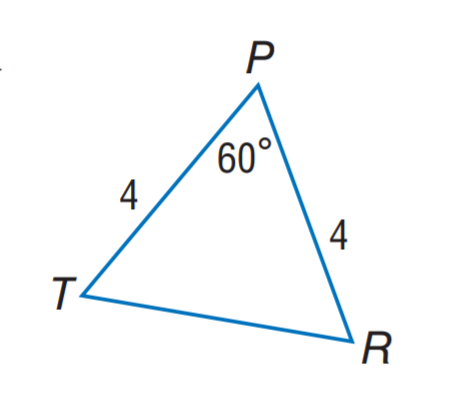Question: Find T R.
Choices:
A. 2
B. 4
C. 5
D. 8
Answer with the letter. Answer: B 